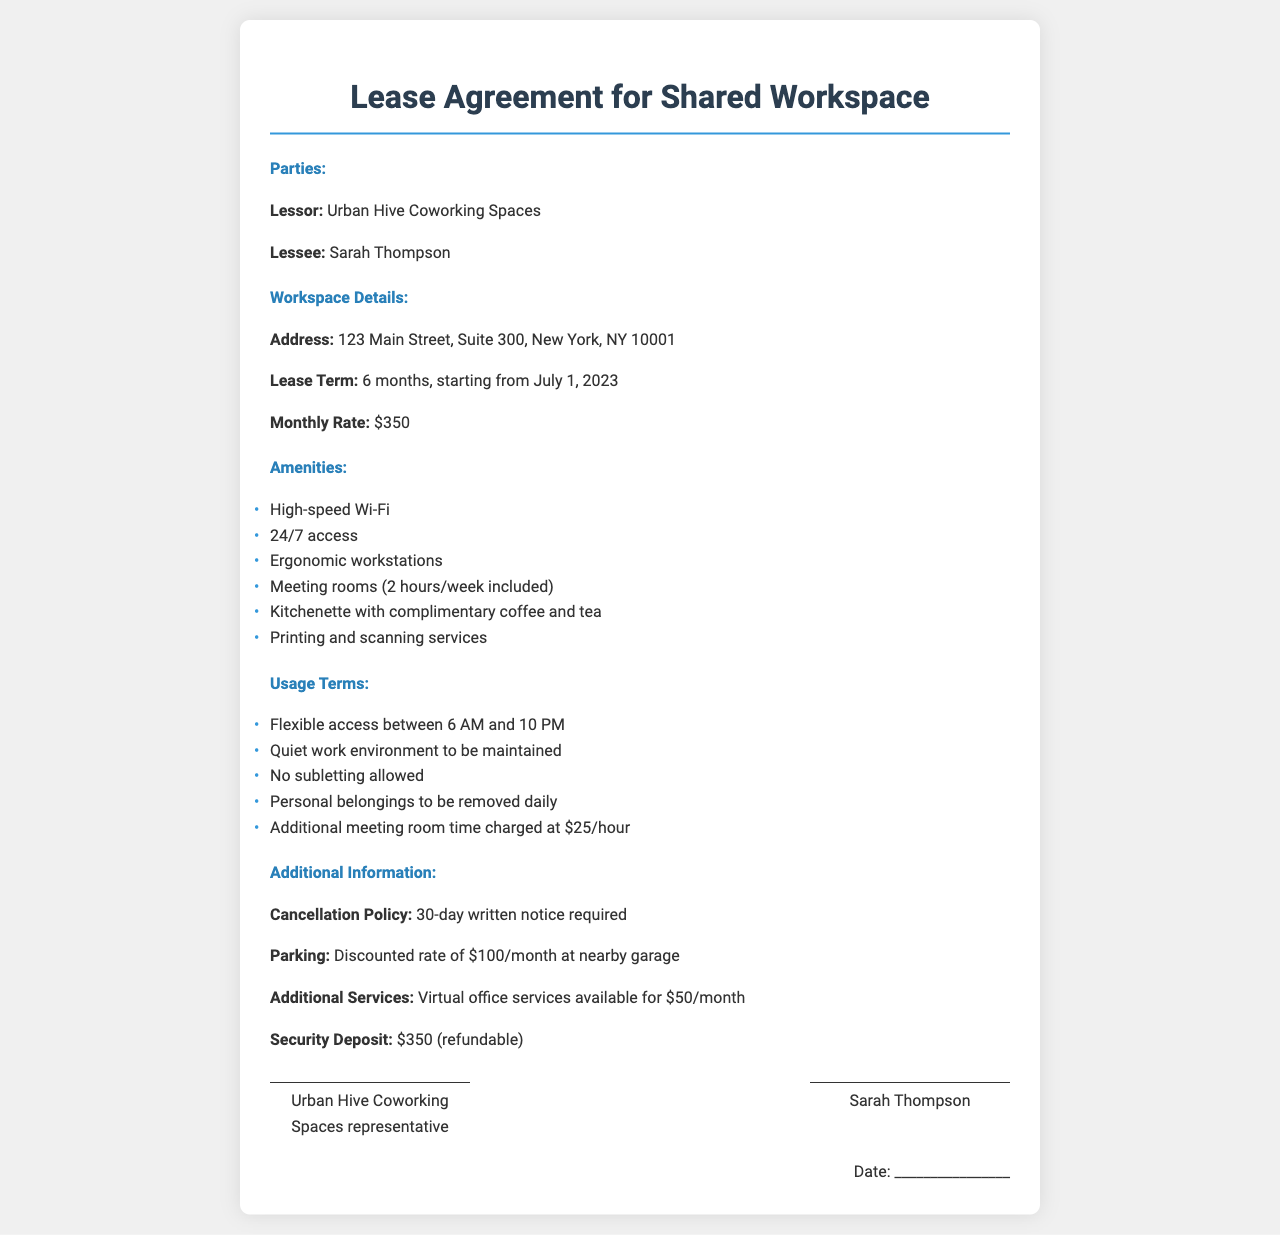What is the address of the workspace? The address is listed under the Workspace Details section of the document.
Answer: 123 Main Street, Suite 300, New York, NY 10001 What is the lease term duration? The lease term duration is specified in the Workspace Details section.
Answer: 6 months What is the monthly rate of the lease? The monthly rate is mentioned in the Workspace Details section of the document.
Answer: $350 How many hours of meeting room usage are included each week? The included meeting room usage is stated in the Amenities section.
Answer: 2 hours/week What time is the workspace accessible to users? The access time is detailed under the Usage Terms section.
Answer: 6 AM to 10 PM What is the security deposit amount? The security deposit amount is mentioned in the Additional Information section.
Answer: $350 Is subletting allowed in this workspace? This information is found in the Usage Terms section of the document.
Answer: No What is the cancellation notice period? The cancellation notice is detailed in the Additional Information section.
Answer: 30-day written notice What additional service is available for $50 per month? The additional service is listed in the Additional Information section of the document.
Answer: Virtual office services 